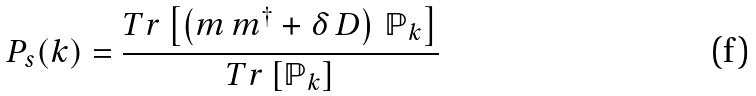<formula> <loc_0><loc_0><loc_500><loc_500>P _ { s } ( k ) = { \frac { T r \left [ \left ( m \, m ^ { \dagger } + \delta \, D \right ) \, \mathbb { P } _ { k } \right ] } { T r \left [ \mathbb { P } _ { k } \right ] } }</formula> 